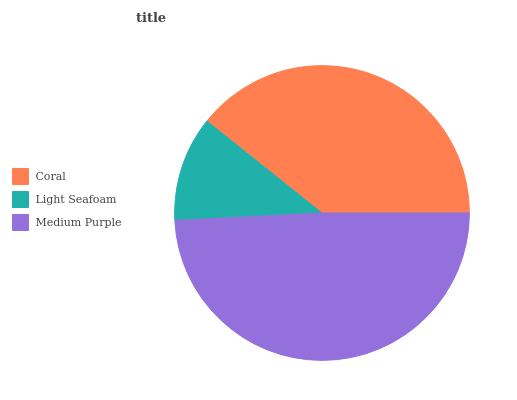Is Light Seafoam the minimum?
Answer yes or no. Yes. Is Medium Purple the maximum?
Answer yes or no. Yes. Is Medium Purple the minimum?
Answer yes or no. No. Is Light Seafoam the maximum?
Answer yes or no. No. Is Medium Purple greater than Light Seafoam?
Answer yes or no. Yes. Is Light Seafoam less than Medium Purple?
Answer yes or no. Yes. Is Light Seafoam greater than Medium Purple?
Answer yes or no. No. Is Medium Purple less than Light Seafoam?
Answer yes or no. No. Is Coral the high median?
Answer yes or no. Yes. Is Coral the low median?
Answer yes or no. Yes. Is Medium Purple the high median?
Answer yes or no. No. Is Light Seafoam the low median?
Answer yes or no. No. 